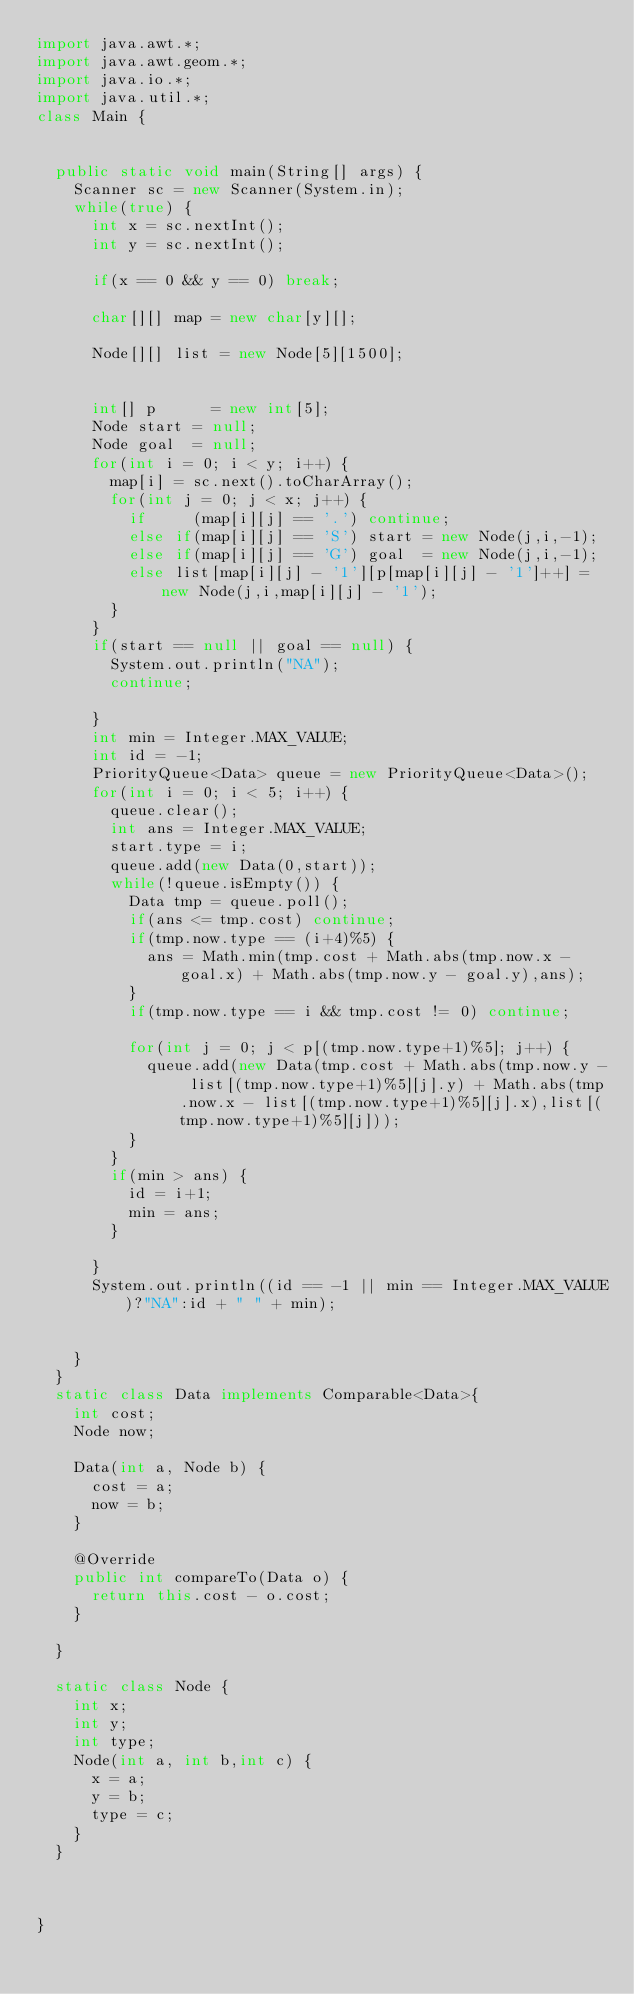Convert code to text. <code><loc_0><loc_0><loc_500><loc_500><_Java_>import java.awt.*;
import java.awt.geom.*;
import java.io.*;
import java.util.*;
class Main {


	public static void main(String[] args) {
		Scanner sc = new Scanner(System.in);
		while(true) {
			int x = sc.nextInt();
			int y = sc.nextInt();
			
			if(x == 0 && y == 0) break;
			
			char[][] map = new char[y][];
			
			Node[][] list = new Node[5][1500];


			int[] p      = new int[5];
			Node start = null;
			Node goal  = null;
			for(int i = 0; i < y; i++) {
				map[i] = sc.next().toCharArray();
				for(int j = 0; j < x; j++) {
					if     (map[i][j] == '.') continue;
					else if(map[i][j] == 'S') start = new Node(j,i,-1);
					else if(map[i][j] == 'G') goal  = new Node(j,i,-1);
					else list[map[i][j] - '1'][p[map[i][j] - '1']++] = new Node(j,i,map[i][j] - '1');
				}
			}
			if(start == null || goal == null) {
				System.out.println("NA");
				continue;
			
			}
			int min = Integer.MAX_VALUE;
			int id = -1;
			PriorityQueue<Data> queue = new PriorityQueue<Data>();
			for(int i = 0; i < 5; i++) {
				queue.clear();
				int ans = Integer.MAX_VALUE;
				start.type = i;
				queue.add(new Data(0,start));
				while(!queue.isEmpty()) {
					Data tmp = queue.poll();
					if(ans <= tmp.cost) continue;
					if(tmp.now.type == (i+4)%5) {
						ans = Math.min(tmp.cost + Math.abs(tmp.now.x - goal.x) + Math.abs(tmp.now.y - goal.y),ans);
					}
					if(tmp.now.type == i && tmp.cost != 0) continue;
					
					for(int j = 0; j < p[(tmp.now.type+1)%5]; j++) {
						queue.add(new Data(tmp.cost + Math.abs(tmp.now.y - list[(tmp.now.type+1)%5][j].y) + Math.abs(tmp.now.x - list[(tmp.now.type+1)%5][j].x),list[(tmp.now.type+1)%5][j]));
					}
				}
				if(min > ans) {
					id = i+1;
					min = ans;
				}
				
			}
			System.out.println((id == -1 || min == Integer.MAX_VALUE)?"NA":id + " " + min);
			
			
		}
	}
	static class Data implements Comparable<Data>{
		int cost;
		Node now;
		
		Data(int a, Node b) {
			cost = a;
			now = b;
		}
		
		@Override
		public int compareTo(Data o) {
			return this.cost - o.cost;
		}
		
	}
	
	static class Node {
		int x;
		int y;
		int type;
		Node(int a, int b,int c) {
			x = a;
			y = b;
			type = c;
		}
	}



}</code> 